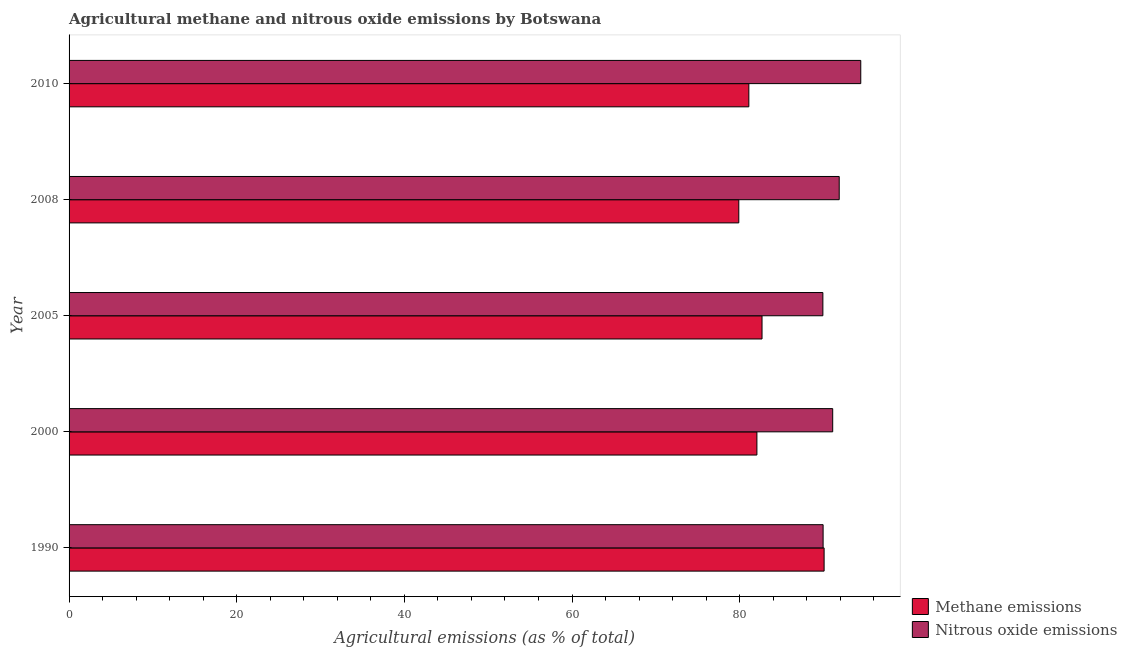How many different coloured bars are there?
Provide a succinct answer. 2. How many groups of bars are there?
Provide a succinct answer. 5. Are the number of bars per tick equal to the number of legend labels?
Your response must be concise. Yes. How many bars are there on the 3rd tick from the top?
Offer a terse response. 2. How many bars are there on the 3rd tick from the bottom?
Provide a succinct answer. 2. What is the label of the 1st group of bars from the top?
Provide a short and direct response. 2010. In how many cases, is the number of bars for a given year not equal to the number of legend labels?
Keep it short and to the point. 0. What is the amount of nitrous oxide emissions in 2000?
Provide a succinct answer. 91.1. Across all years, what is the maximum amount of methane emissions?
Offer a very short reply. 90.08. Across all years, what is the minimum amount of methane emissions?
Your answer should be compact. 79.9. In which year was the amount of methane emissions maximum?
Provide a succinct answer. 1990. In which year was the amount of nitrous oxide emissions minimum?
Make the answer very short. 2005. What is the total amount of nitrous oxide emissions in the graph?
Provide a succinct answer. 457.31. What is the difference between the amount of methane emissions in 1990 and that in 2010?
Make the answer very short. 8.98. What is the difference between the amount of methane emissions in 2005 and the amount of nitrous oxide emissions in 2008?
Ensure brevity in your answer.  -9.21. What is the average amount of nitrous oxide emissions per year?
Your answer should be compact. 91.46. In the year 2005, what is the difference between the amount of methane emissions and amount of nitrous oxide emissions?
Your answer should be very brief. -7.26. In how many years, is the amount of methane emissions greater than 72 %?
Offer a very short reply. 5. Is the difference between the amount of methane emissions in 2008 and 2010 greater than the difference between the amount of nitrous oxide emissions in 2008 and 2010?
Your answer should be compact. Yes. What is the difference between the highest and the second highest amount of methane emissions?
Provide a short and direct response. 7.41. What is the difference between the highest and the lowest amount of nitrous oxide emissions?
Keep it short and to the point. 4.52. Is the sum of the amount of nitrous oxide emissions in 1990 and 2010 greater than the maximum amount of methane emissions across all years?
Ensure brevity in your answer.  Yes. What does the 2nd bar from the top in 2005 represents?
Offer a very short reply. Methane emissions. What does the 2nd bar from the bottom in 1990 represents?
Offer a very short reply. Nitrous oxide emissions. How many bars are there?
Make the answer very short. 10. What is the difference between two consecutive major ticks on the X-axis?
Make the answer very short. 20. Does the graph contain grids?
Your answer should be compact. No. How are the legend labels stacked?
Offer a very short reply. Vertical. What is the title of the graph?
Offer a very short reply. Agricultural methane and nitrous oxide emissions by Botswana. Does "Under-5(female)" appear as one of the legend labels in the graph?
Make the answer very short. No. What is the label or title of the X-axis?
Give a very brief answer. Agricultural emissions (as % of total). What is the label or title of the Y-axis?
Your answer should be compact. Year. What is the Agricultural emissions (as % of total) in Methane emissions in 1990?
Give a very brief answer. 90.08. What is the Agricultural emissions (as % of total) of Nitrous oxide emissions in 1990?
Offer a terse response. 89.96. What is the Agricultural emissions (as % of total) of Methane emissions in 2000?
Offer a very short reply. 82.06. What is the Agricultural emissions (as % of total) of Nitrous oxide emissions in 2000?
Your answer should be very brief. 91.1. What is the Agricultural emissions (as % of total) in Methane emissions in 2005?
Offer a very short reply. 82.67. What is the Agricultural emissions (as % of total) in Nitrous oxide emissions in 2005?
Give a very brief answer. 89.93. What is the Agricultural emissions (as % of total) of Methane emissions in 2008?
Keep it short and to the point. 79.9. What is the Agricultural emissions (as % of total) of Nitrous oxide emissions in 2008?
Ensure brevity in your answer.  91.88. What is the Agricultural emissions (as % of total) of Methane emissions in 2010?
Make the answer very short. 81.1. What is the Agricultural emissions (as % of total) in Nitrous oxide emissions in 2010?
Give a very brief answer. 94.45. Across all years, what is the maximum Agricultural emissions (as % of total) in Methane emissions?
Make the answer very short. 90.08. Across all years, what is the maximum Agricultural emissions (as % of total) in Nitrous oxide emissions?
Offer a very short reply. 94.45. Across all years, what is the minimum Agricultural emissions (as % of total) of Methane emissions?
Your response must be concise. 79.9. Across all years, what is the minimum Agricultural emissions (as % of total) in Nitrous oxide emissions?
Offer a terse response. 89.93. What is the total Agricultural emissions (as % of total) in Methane emissions in the graph?
Provide a succinct answer. 415.8. What is the total Agricultural emissions (as % of total) of Nitrous oxide emissions in the graph?
Provide a succinct answer. 457.31. What is the difference between the Agricultural emissions (as % of total) in Methane emissions in 1990 and that in 2000?
Make the answer very short. 8.02. What is the difference between the Agricultural emissions (as % of total) of Nitrous oxide emissions in 1990 and that in 2000?
Make the answer very short. -1.14. What is the difference between the Agricultural emissions (as % of total) of Methane emissions in 1990 and that in 2005?
Keep it short and to the point. 7.41. What is the difference between the Agricultural emissions (as % of total) in Nitrous oxide emissions in 1990 and that in 2005?
Offer a very short reply. 0.03. What is the difference between the Agricultural emissions (as % of total) in Methane emissions in 1990 and that in 2008?
Your response must be concise. 10.18. What is the difference between the Agricultural emissions (as % of total) of Nitrous oxide emissions in 1990 and that in 2008?
Your answer should be very brief. -1.92. What is the difference between the Agricultural emissions (as % of total) in Methane emissions in 1990 and that in 2010?
Offer a terse response. 8.98. What is the difference between the Agricultural emissions (as % of total) of Nitrous oxide emissions in 1990 and that in 2010?
Give a very brief answer. -4.49. What is the difference between the Agricultural emissions (as % of total) of Methane emissions in 2000 and that in 2005?
Make the answer very short. -0.61. What is the difference between the Agricultural emissions (as % of total) in Nitrous oxide emissions in 2000 and that in 2005?
Offer a very short reply. 1.17. What is the difference between the Agricultural emissions (as % of total) of Methane emissions in 2000 and that in 2008?
Give a very brief answer. 2.16. What is the difference between the Agricultural emissions (as % of total) in Nitrous oxide emissions in 2000 and that in 2008?
Give a very brief answer. -0.78. What is the difference between the Agricultural emissions (as % of total) of Methane emissions in 2000 and that in 2010?
Give a very brief answer. 0.96. What is the difference between the Agricultural emissions (as % of total) of Nitrous oxide emissions in 2000 and that in 2010?
Provide a short and direct response. -3.35. What is the difference between the Agricultural emissions (as % of total) in Methane emissions in 2005 and that in 2008?
Your answer should be compact. 2.77. What is the difference between the Agricultural emissions (as % of total) in Nitrous oxide emissions in 2005 and that in 2008?
Your response must be concise. -1.95. What is the difference between the Agricultural emissions (as % of total) of Methane emissions in 2005 and that in 2010?
Offer a very short reply. 1.57. What is the difference between the Agricultural emissions (as % of total) of Nitrous oxide emissions in 2005 and that in 2010?
Give a very brief answer. -4.52. What is the difference between the Agricultural emissions (as % of total) in Methane emissions in 2008 and that in 2010?
Offer a very short reply. -1.2. What is the difference between the Agricultural emissions (as % of total) in Nitrous oxide emissions in 2008 and that in 2010?
Provide a succinct answer. -2.57. What is the difference between the Agricultural emissions (as % of total) in Methane emissions in 1990 and the Agricultural emissions (as % of total) in Nitrous oxide emissions in 2000?
Offer a very short reply. -1.02. What is the difference between the Agricultural emissions (as % of total) of Methane emissions in 1990 and the Agricultural emissions (as % of total) of Nitrous oxide emissions in 2005?
Your answer should be very brief. 0.15. What is the difference between the Agricultural emissions (as % of total) of Methane emissions in 1990 and the Agricultural emissions (as % of total) of Nitrous oxide emissions in 2008?
Provide a short and direct response. -1.8. What is the difference between the Agricultural emissions (as % of total) in Methane emissions in 1990 and the Agricultural emissions (as % of total) in Nitrous oxide emissions in 2010?
Your answer should be very brief. -4.37. What is the difference between the Agricultural emissions (as % of total) in Methane emissions in 2000 and the Agricultural emissions (as % of total) in Nitrous oxide emissions in 2005?
Your answer should be very brief. -7.87. What is the difference between the Agricultural emissions (as % of total) of Methane emissions in 2000 and the Agricultural emissions (as % of total) of Nitrous oxide emissions in 2008?
Give a very brief answer. -9.82. What is the difference between the Agricultural emissions (as % of total) in Methane emissions in 2000 and the Agricultural emissions (as % of total) in Nitrous oxide emissions in 2010?
Your answer should be compact. -12.39. What is the difference between the Agricultural emissions (as % of total) in Methane emissions in 2005 and the Agricultural emissions (as % of total) in Nitrous oxide emissions in 2008?
Your answer should be compact. -9.21. What is the difference between the Agricultural emissions (as % of total) of Methane emissions in 2005 and the Agricultural emissions (as % of total) of Nitrous oxide emissions in 2010?
Provide a short and direct response. -11.78. What is the difference between the Agricultural emissions (as % of total) in Methane emissions in 2008 and the Agricultural emissions (as % of total) in Nitrous oxide emissions in 2010?
Offer a terse response. -14.55. What is the average Agricultural emissions (as % of total) of Methane emissions per year?
Provide a succinct answer. 83.16. What is the average Agricultural emissions (as % of total) in Nitrous oxide emissions per year?
Keep it short and to the point. 91.46. In the year 1990, what is the difference between the Agricultural emissions (as % of total) in Methane emissions and Agricultural emissions (as % of total) in Nitrous oxide emissions?
Ensure brevity in your answer.  0.12. In the year 2000, what is the difference between the Agricultural emissions (as % of total) of Methane emissions and Agricultural emissions (as % of total) of Nitrous oxide emissions?
Provide a succinct answer. -9.04. In the year 2005, what is the difference between the Agricultural emissions (as % of total) of Methane emissions and Agricultural emissions (as % of total) of Nitrous oxide emissions?
Make the answer very short. -7.26. In the year 2008, what is the difference between the Agricultural emissions (as % of total) in Methane emissions and Agricultural emissions (as % of total) in Nitrous oxide emissions?
Ensure brevity in your answer.  -11.98. In the year 2010, what is the difference between the Agricultural emissions (as % of total) of Methane emissions and Agricultural emissions (as % of total) of Nitrous oxide emissions?
Offer a very short reply. -13.35. What is the ratio of the Agricultural emissions (as % of total) in Methane emissions in 1990 to that in 2000?
Give a very brief answer. 1.1. What is the ratio of the Agricultural emissions (as % of total) in Nitrous oxide emissions in 1990 to that in 2000?
Make the answer very short. 0.99. What is the ratio of the Agricultural emissions (as % of total) in Methane emissions in 1990 to that in 2005?
Give a very brief answer. 1.09. What is the ratio of the Agricultural emissions (as % of total) of Methane emissions in 1990 to that in 2008?
Offer a terse response. 1.13. What is the ratio of the Agricultural emissions (as % of total) in Nitrous oxide emissions in 1990 to that in 2008?
Make the answer very short. 0.98. What is the ratio of the Agricultural emissions (as % of total) of Methane emissions in 1990 to that in 2010?
Provide a short and direct response. 1.11. What is the ratio of the Agricultural emissions (as % of total) in Nitrous oxide emissions in 1990 to that in 2010?
Keep it short and to the point. 0.95. What is the ratio of the Agricultural emissions (as % of total) in Nitrous oxide emissions in 2000 to that in 2005?
Provide a short and direct response. 1.01. What is the ratio of the Agricultural emissions (as % of total) of Methane emissions in 2000 to that in 2008?
Offer a terse response. 1.03. What is the ratio of the Agricultural emissions (as % of total) of Nitrous oxide emissions in 2000 to that in 2008?
Provide a short and direct response. 0.99. What is the ratio of the Agricultural emissions (as % of total) in Methane emissions in 2000 to that in 2010?
Your answer should be very brief. 1.01. What is the ratio of the Agricultural emissions (as % of total) of Nitrous oxide emissions in 2000 to that in 2010?
Give a very brief answer. 0.96. What is the ratio of the Agricultural emissions (as % of total) of Methane emissions in 2005 to that in 2008?
Ensure brevity in your answer.  1.03. What is the ratio of the Agricultural emissions (as % of total) of Nitrous oxide emissions in 2005 to that in 2008?
Your answer should be compact. 0.98. What is the ratio of the Agricultural emissions (as % of total) in Methane emissions in 2005 to that in 2010?
Your answer should be compact. 1.02. What is the ratio of the Agricultural emissions (as % of total) of Nitrous oxide emissions in 2005 to that in 2010?
Make the answer very short. 0.95. What is the ratio of the Agricultural emissions (as % of total) in Methane emissions in 2008 to that in 2010?
Provide a succinct answer. 0.99. What is the ratio of the Agricultural emissions (as % of total) in Nitrous oxide emissions in 2008 to that in 2010?
Keep it short and to the point. 0.97. What is the difference between the highest and the second highest Agricultural emissions (as % of total) of Methane emissions?
Ensure brevity in your answer.  7.41. What is the difference between the highest and the second highest Agricultural emissions (as % of total) of Nitrous oxide emissions?
Provide a short and direct response. 2.57. What is the difference between the highest and the lowest Agricultural emissions (as % of total) of Methane emissions?
Your response must be concise. 10.18. What is the difference between the highest and the lowest Agricultural emissions (as % of total) in Nitrous oxide emissions?
Your answer should be very brief. 4.52. 